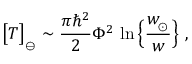Convert formula to latex. <formula><loc_0><loc_0><loc_500><loc_500>\left [ T \right ] _ { _ { \ominus } } \sim { \frac { \pi \hbar { ^ } { 2 } } { 2 } } \Phi ^ { 2 } \, \ln \left \{ { \frac { w _ { \, _ { \odot } } } { w } } \right \} \ ,</formula> 